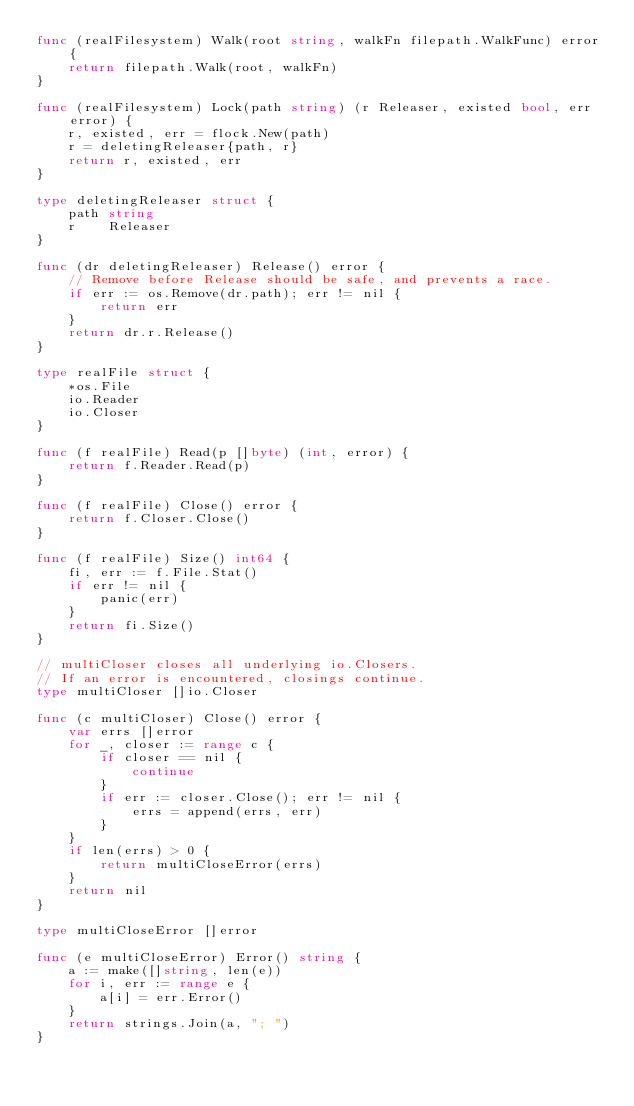Convert code to text. <code><loc_0><loc_0><loc_500><loc_500><_Go_>func (realFilesystem) Walk(root string, walkFn filepath.WalkFunc) error {
	return filepath.Walk(root, walkFn)
}

func (realFilesystem) Lock(path string) (r Releaser, existed bool, err error) {
	r, existed, err = flock.New(path)
	r = deletingReleaser{path, r}
	return r, existed, err
}

type deletingReleaser struct {
	path string
	r    Releaser
}

func (dr deletingReleaser) Release() error {
	// Remove before Release should be safe, and prevents a race.
	if err := os.Remove(dr.path); err != nil {
		return err
	}
	return dr.r.Release()
}

type realFile struct {
	*os.File
	io.Reader
	io.Closer
}

func (f realFile) Read(p []byte) (int, error) {
	return f.Reader.Read(p)
}

func (f realFile) Close() error {
	return f.Closer.Close()
}

func (f realFile) Size() int64 {
	fi, err := f.File.Stat()
	if err != nil {
		panic(err)
	}
	return fi.Size()
}

// multiCloser closes all underlying io.Closers.
// If an error is encountered, closings continue.
type multiCloser []io.Closer

func (c multiCloser) Close() error {
	var errs []error
	for _, closer := range c {
		if closer == nil {
			continue
		}
		if err := closer.Close(); err != nil {
			errs = append(errs, err)
		}
	}
	if len(errs) > 0 {
		return multiCloseError(errs)
	}
	return nil
}

type multiCloseError []error

func (e multiCloseError) Error() string {
	a := make([]string, len(e))
	for i, err := range e {
		a[i] = err.Error()
	}
	return strings.Join(a, "; ")
}
</code> 